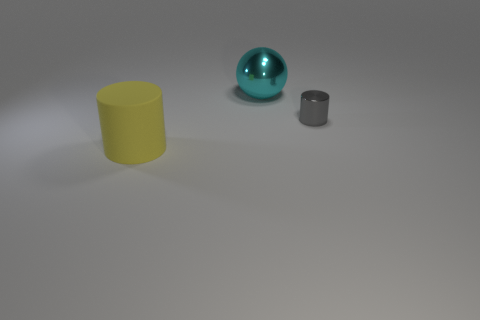Is there any other thing that has the same material as the large yellow cylinder?
Your response must be concise. No. How many big objects are either metallic things or yellow matte cylinders?
Offer a terse response. 2. Are there any other things that have the same color as the large shiny object?
Provide a succinct answer. No. There is a cylinder that is on the left side of the gray metallic cylinder; does it have the same size as the big metallic thing?
Ensure brevity in your answer.  Yes. What is the color of the large object that is behind the large object in front of the cylinder to the right of the big metal object?
Your answer should be very brief. Cyan. What is the color of the metal cylinder?
Keep it short and to the point. Gray. Are the cylinder on the right side of the big sphere and the big object that is right of the large yellow matte thing made of the same material?
Your answer should be very brief. Yes. There is another thing that is the same shape as the large yellow matte object; what is it made of?
Your response must be concise. Metal. Is the material of the small cylinder the same as the yellow object?
Provide a succinct answer. No. The big object that is on the right side of the yellow rubber cylinder that is in front of the big shiny ball is what color?
Give a very brief answer. Cyan. 